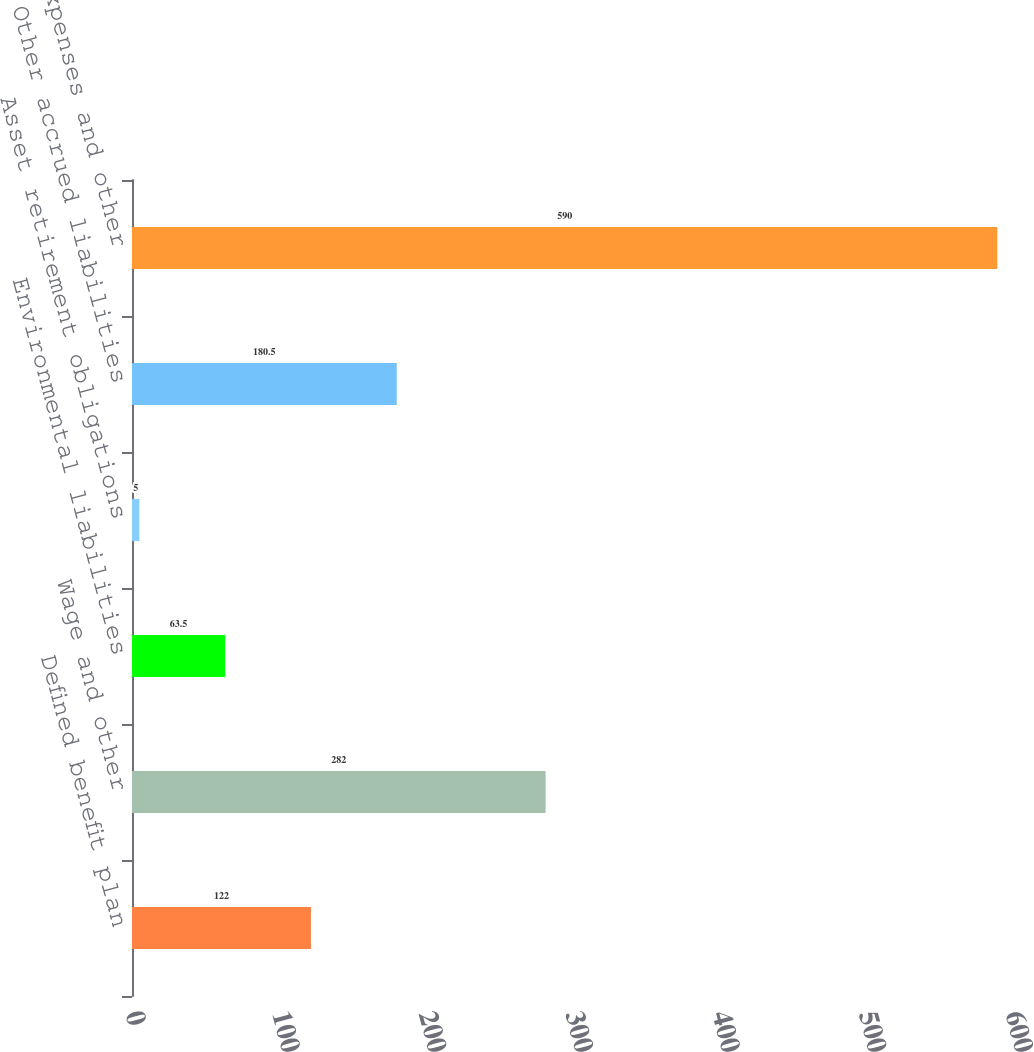Convert chart to OTSL. <chart><loc_0><loc_0><loc_500><loc_500><bar_chart><fcel>Defined benefit plan<fcel>Wage and other<fcel>Environmental liabilities<fcel>Asset retirement obligations<fcel>Other accrued liabilities<fcel>Accrued expenses and other<nl><fcel>122<fcel>282<fcel>63.5<fcel>5<fcel>180.5<fcel>590<nl></chart> 